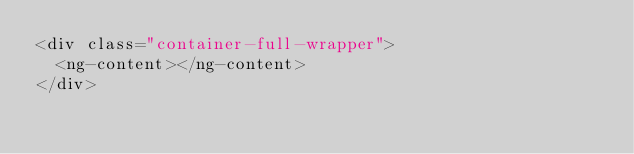Convert code to text. <code><loc_0><loc_0><loc_500><loc_500><_HTML_><div class="container-full-wrapper">
  <ng-content></ng-content>
</div>
</code> 